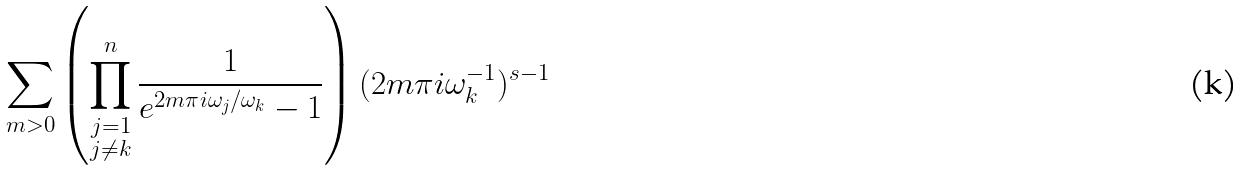Convert formula to latex. <formula><loc_0><loc_0><loc_500><loc_500>\sum _ { m > 0 } \left ( \prod _ { \substack { j = 1 \\ j \neq k } } ^ { n } \frac { 1 } { e ^ { 2 m \pi i \omega _ { j } / \omega _ { k } } - 1 } \right ) ( 2 m \pi i \omega _ { k } ^ { - 1 } ) ^ { s - 1 }</formula> 